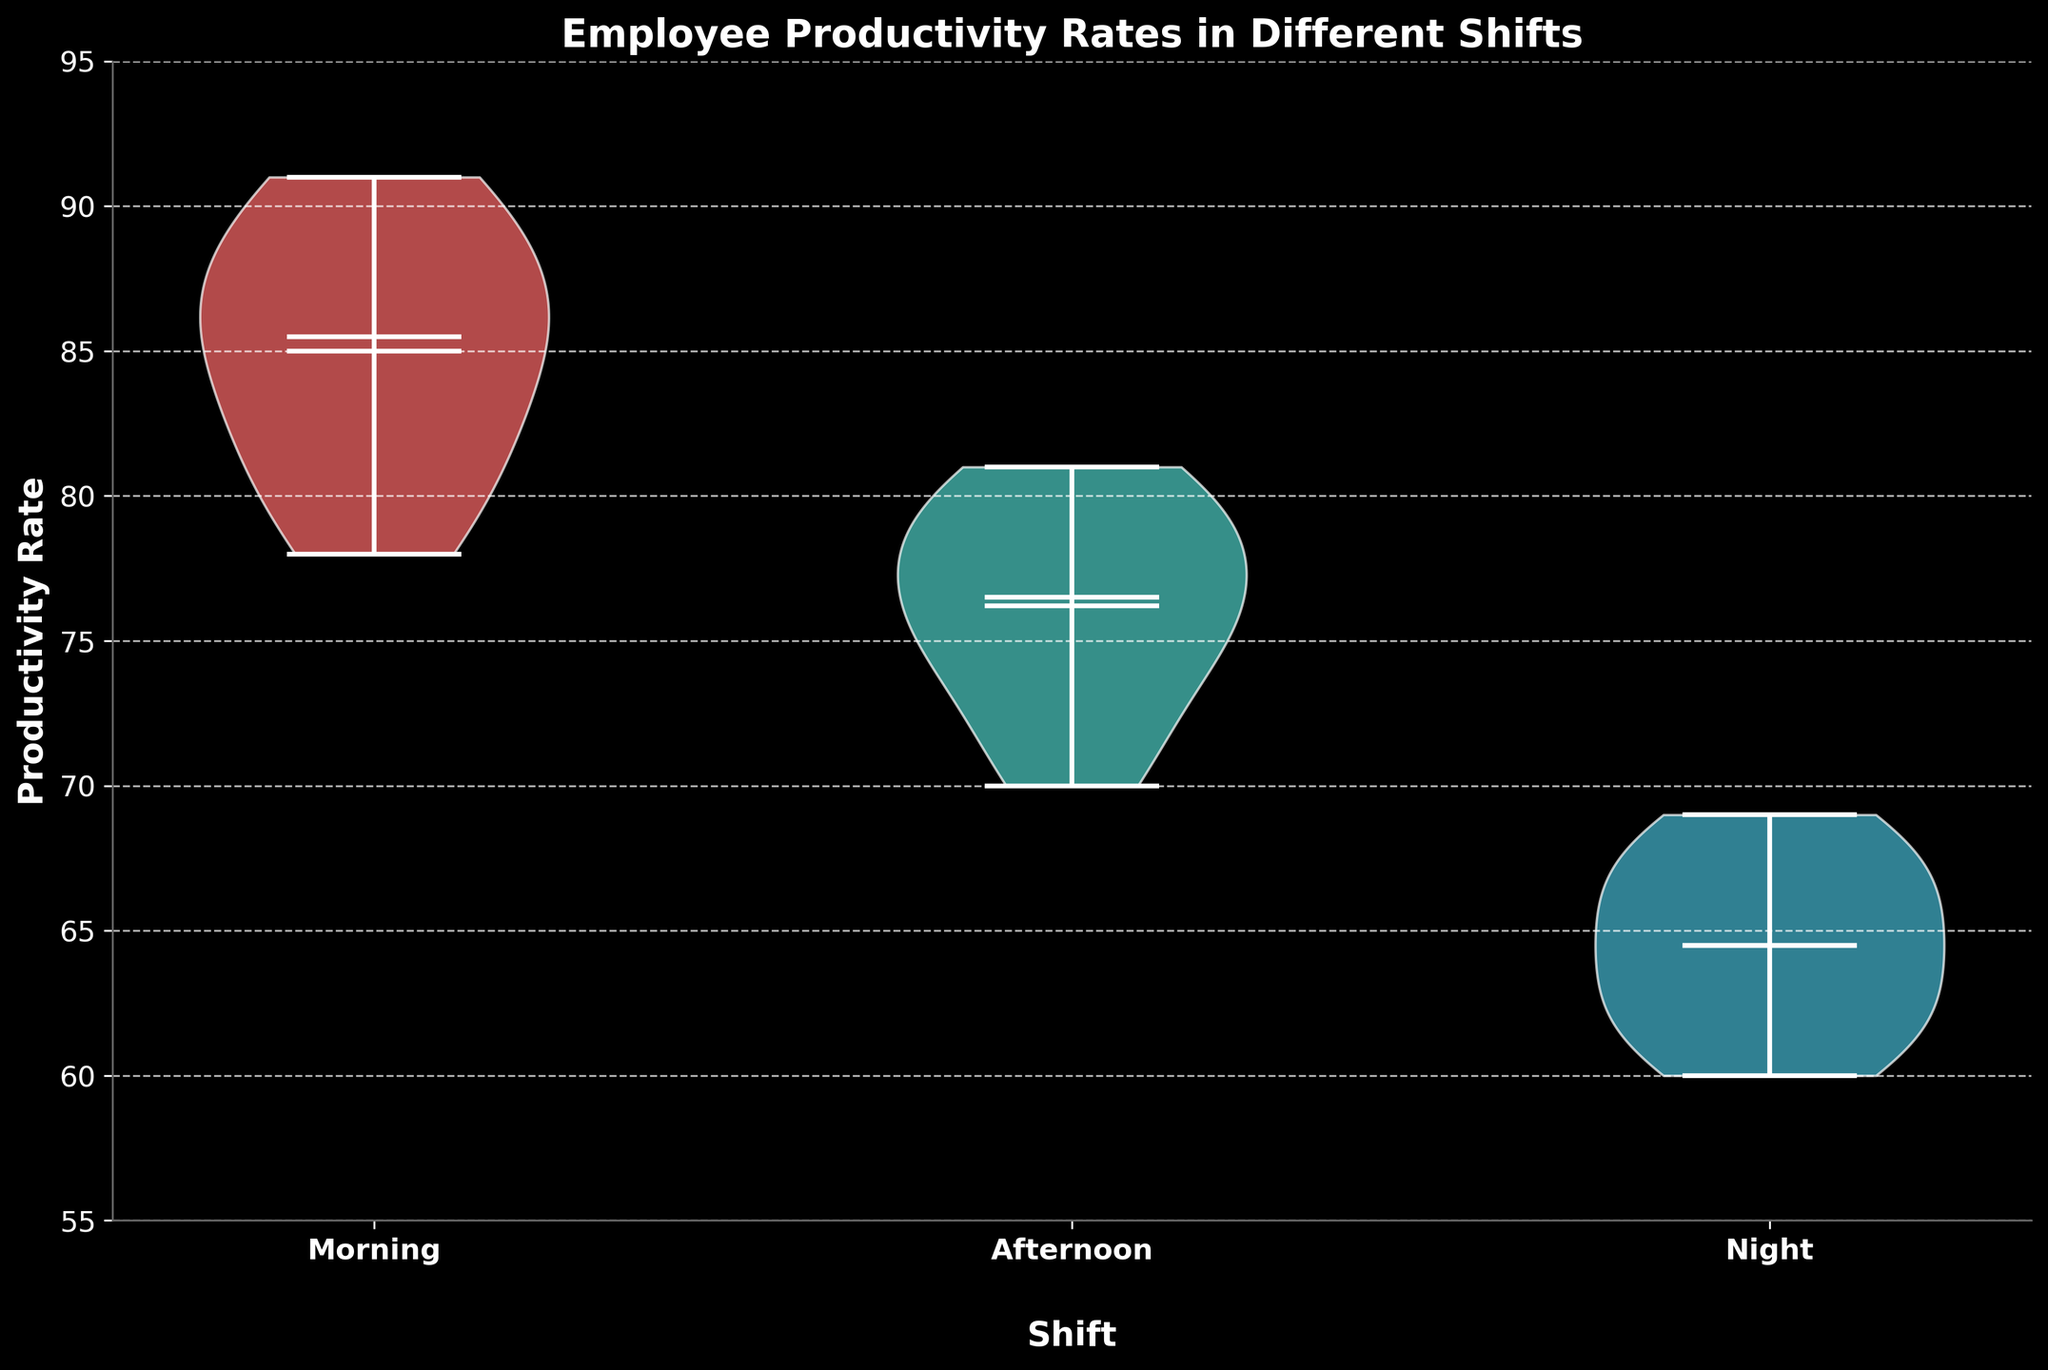What is the title of the plot? The title is usually located at the top of the plot and provides an overview of what the data represents.
Answer: Employee Productivity Rates in Different Shifts What are the shifts compared in the plot? By looking at the x-axis labels, you can determine which shifts are included. They are displayed as distinct categories.
Answer: Morning, Afternoon, Night Which shift has the highest median productivity rate? The highest median productivity rate can be identified by looking at the position of the median line within each violin chart.
Answer: Morning What is the range of productivity rates for the night shift? The range can be determined by observing the minimum and maximum lines (whiskers) for the night shift violin plot.
Answer: 60 to 69 How does the mean productivity rate compare between the morning and afternoon shifts? The mean productivity rate is indicated by a dot in each violin plot. Comparing the positions of these dots gives the answer.
Answer: The morning shift has a higher mean productivity rate than the afternoon shift Which shift has the smallest variability in productivity rates? The shift with the narrowest and most enclosed violin plot indicates the smallest variability.
Answer: Morning Is there an overlap in the productivity rates between any of the shifts? Overlap is determined by looking at the extension of the violin plots across the productivity rate axis.
Answer: Yes, there is an overlap between the morning and afternoon shifts What is the productivity rate at the lower quartile for the afternoon shift? The lower quartile can be estimated by the bottom quarter of the density area of the violin plot for the afternoon shift.
Answer: Approximately 72 Which shift shows the lowest mean productivity rate? The shift with the lowest placed mean dot will indicate the lowest mean productivity rate.
Answer: Night What is the interquartile range (IQR) of the productivity rates for the morning shift? The IQR is the range where the middle 50% of data points lie and can be estimated by observing the spread within the dense area of the violin plot for the morning shift.
Answer: Approximately 82 to 88 